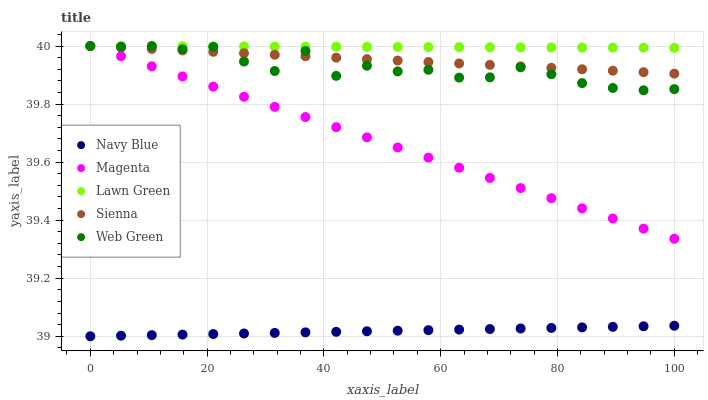Does Navy Blue have the minimum area under the curve?
Answer yes or no. Yes. Does Lawn Green have the maximum area under the curve?
Answer yes or no. Yes. Does Magenta have the minimum area under the curve?
Answer yes or no. No. Does Magenta have the maximum area under the curve?
Answer yes or no. No. Is Lawn Green the smoothest?
Answer yes or no. Yes. Is Web Green the roughest?
Answer yes or no. Yes. Is Navy Blue the smoothest?
Answer yes or no. No. Is Navy Blue the roughest?
Answer yes or no. No. Does Navy Blue have the lowest value?
Answer yes or no. Yes. Does Magenta have the lowest value?
Answer yes or no. No. Does Lawn Green have the highest value?
Answer yes or no. Yes. Does Navy Blue have the highest value?
Answer yes or no. No. Is Navy Blue less than Sienna?
Answer yes or no. Yes. Is Magenta greater than Navy Blue?
Answer yes or no. Yes. Does Sienna intersect Magenta?
Answer yes or no. Yes. Is Sienna less than Magenta?
Answer yes or no. No. Is Sienna greater than Magenta?
Answer yes or no. No. Does Navy Blue intersect Sienna?
Answer yes or no. No. 